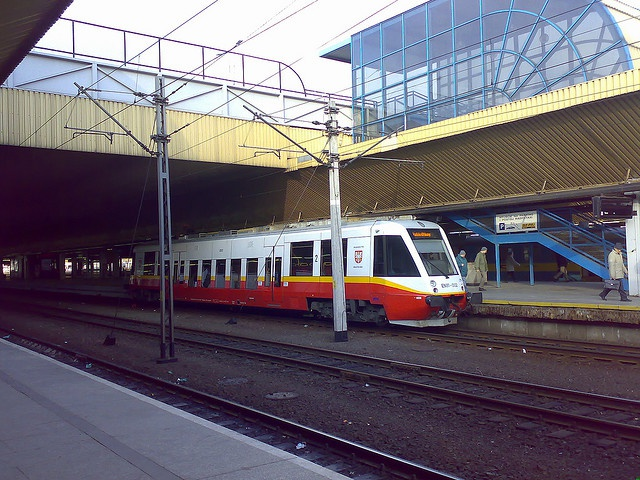Describe the objects in this image and their specific colors. I can see train in black, white, brown, and maroon tones, people in black, darkgray, gray, and lightgray tones, people in black and gray tones, people in black and gray tones, and people in black, blue, and gray tones in this image. 